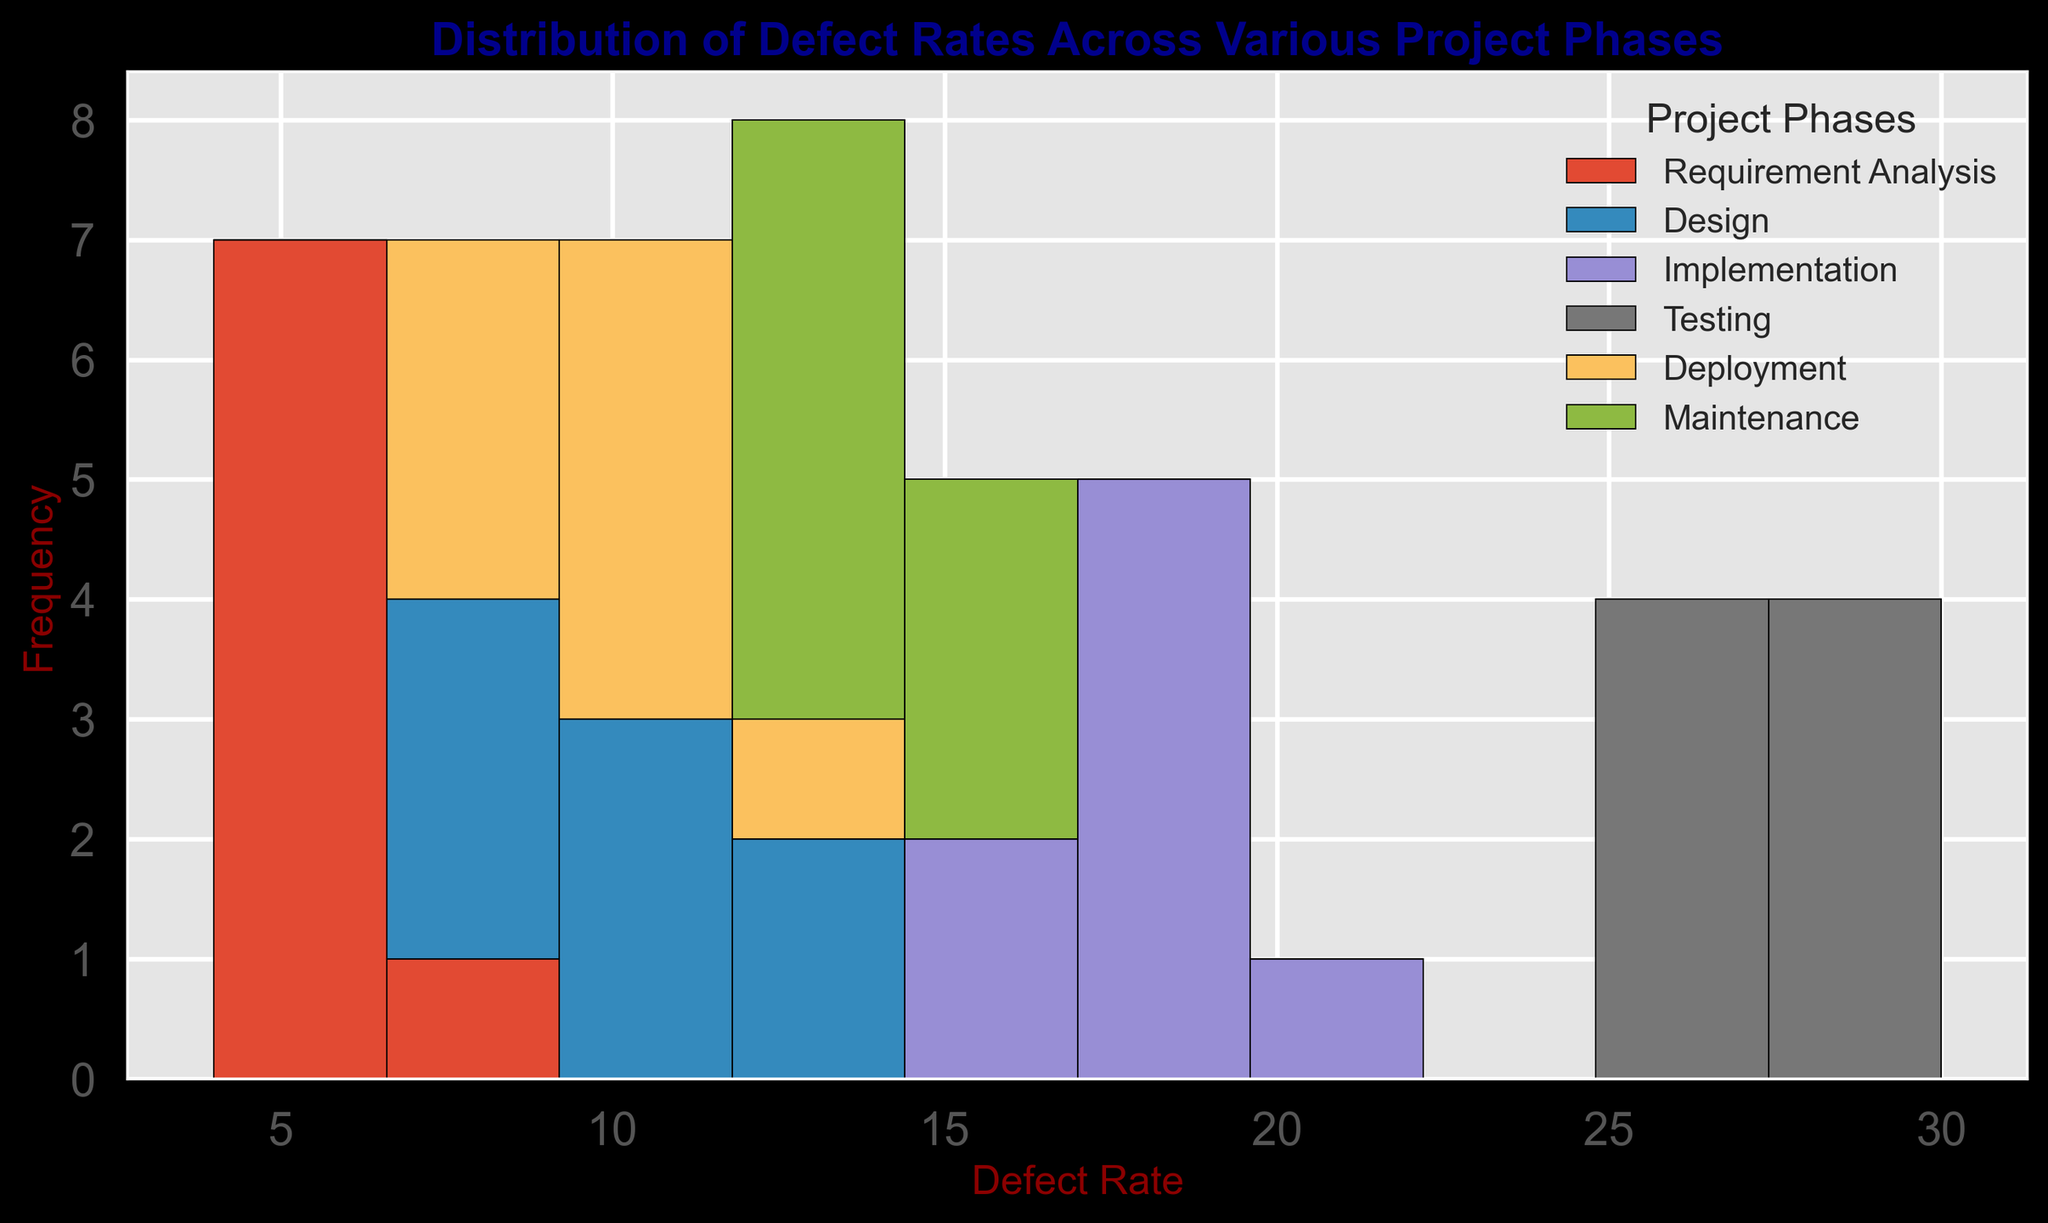Which project phase has the highest defect rates? By observing the histogram, we notice that the 'Testing' phase has the highest deflect rates, as the bars representing it are concentrated around the higher defect rate values (25-30).
Answer: Testing Which phase has the most consistent defect rates? The 'Requirement Analysis' phase shows the most consistent defect rates since its bars are closely clustered around the values 4 to 7, indicating less variance.
Answer: Requirement Analysis What is the combined range of defect rates for 'Design' and 'Deployment' phases? The defect rates for 'Design' phase range from 8 to 12, and for 'Deployment' phase they range from 8 to 12 as well. The combined range is from the minimum of both (8) to the maximum of both (12).
Answer: 8 to 12 How do the defect rates of 'Implementation' compare to 'Maintenance'? 'Implementation' has defect rates ranging from 15 to 20, while 'Maintenance' ranges from 13 to 16. Implementation's rates are consistently higher than those of Maintenance.
Answer: Implementation's rates are higher Which phase shows the greatest variability in defect rates? The 'Testing' phase shows the greatest variability as its defect rates span a wider range (25 to 30) compared to other phases.
Answer: Testing Between 'Design' and 'Requirement Analysis', which phase has more defect occurrences at higher rates? 'Design' has defect occurrences primarily between 8 and 12, while 'Requirement Analysis' has occurrences between 4 and 7. Thus, 'Design' has more occurrences at higher rates.
Answer: Design If we combine the bars of 'Implementation' and 'Testing' phases, what would the total frequency of defect rates in the range of 25 to 30 be? 'Implementation' has no defect rates in the range of 25 to 30, but 'Testing' has defect rates concentrated in this range with a frequency of 8 occurrences (as there are 8 bars for 'Testing' in this range). So, the total frequency is 8.
Answer: 8 What is the average defect rate in the 'Maintenance' phase? The defect rates for 'Maintenance' are 15, 14, 16, 13, 15, 14, 13, and 14. The sum is 114, divided by the 8 data points, the average defect rate is 114/8 = 14.25.
Answer: 14.25 